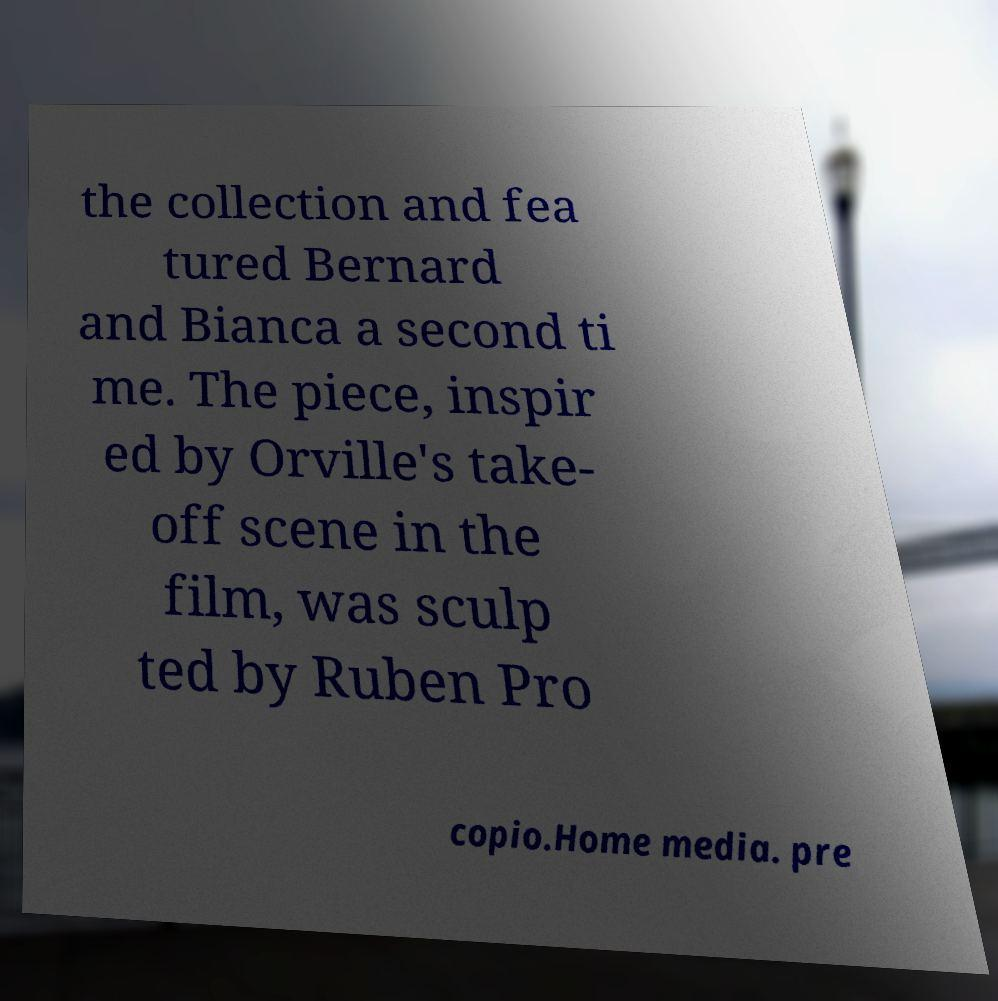I need the written content from this picture converted into text. Can you do that? the collection and fea tured Bernard and Bianca a second ti me. The piece, inspir ed by Orville's take- off scene in the film, was sculp ted by Ruben Pro copio.Home media. pre 